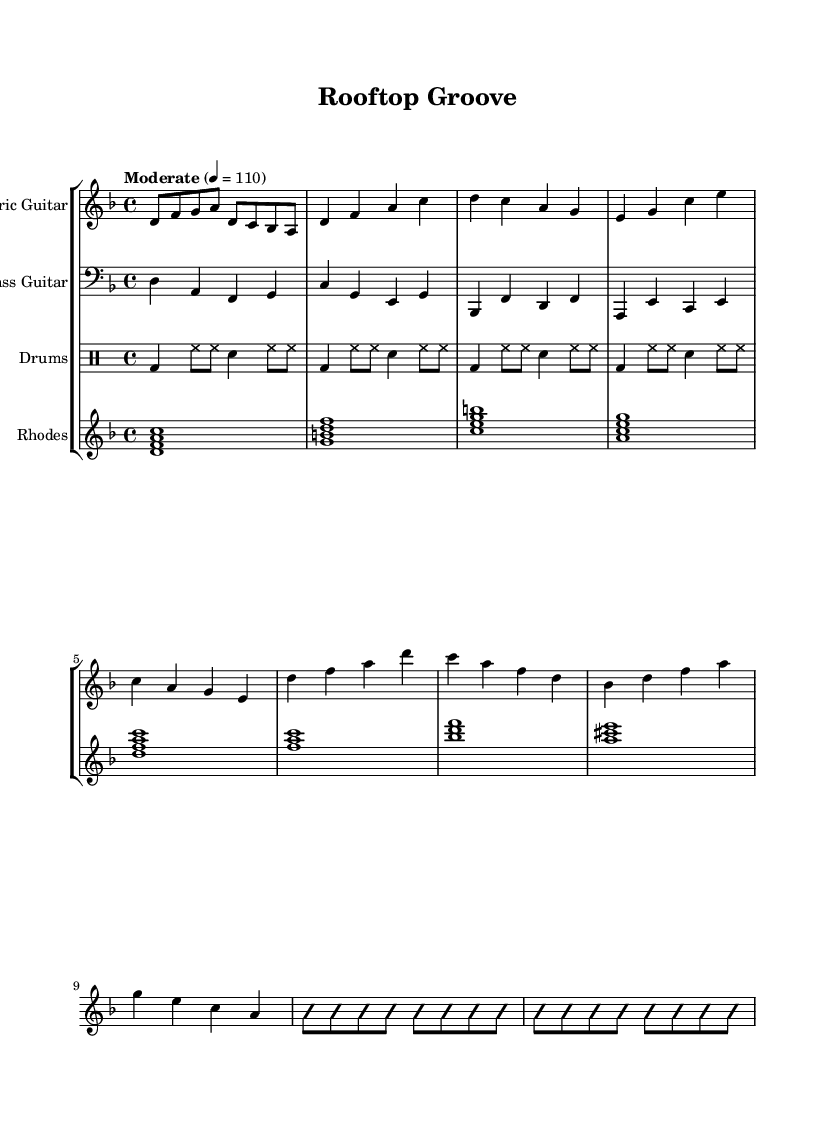What is the key signature of this music? The key signature is D minor, indicated by one flat (B flat). This is determined by the global musical context provided at the beginning of the score, where it specifies the key as D minor.
Answer: D minor What is the time signature of this music? The time signature is 4/4, appearing at the beginning of the piece in the global context. This means there are four beats in each measure and the quarter note receives one beat.
Answer: 4/4 What is the tempo marking for this piece? The tempo marking is Moderate, with a specific metronome marking of 110 beats per minute. This information is found directly in the global context of the score, indicating the intended speed for performance.
Answer: Moderate 4 = 110 How many measures are there in the verse section? There are four measures in the verse section, which can be counted from the electric guitar part where the verse starts with the notes d4 f a c and continues through the indicated music section.
Answer: 4 What instruments are used in this composition? The instruments used are Electric Guitar, Bass Guitar, Drums, and Rhodes Piano. This information can be confirmed by the titles found above each staff in the score, which lists the various instruments playing throughout the piece.
Answer: Electric Guitar, Bass Guitar, Drums, Rhodes Piano Which element indicates improvisation in the solo section? The element that indicates improvisation is the use of the words "improvisationOn" and "improvisationOff," which denote the beginning and end of the guitar solo improvisation section, suggesting a free-form playing style typical in jazz.
Answer: Improvisation What type of jazz elements are present in this piece? The jazz elements present in this piece are fusion jazz and rock elements, as indicated in the title and reflected in the use of electric guitar riffs, intricate rhythms from drums, and a mix of chord progressions typical of both genres.
Answer: Fusion jazz and rock elements 